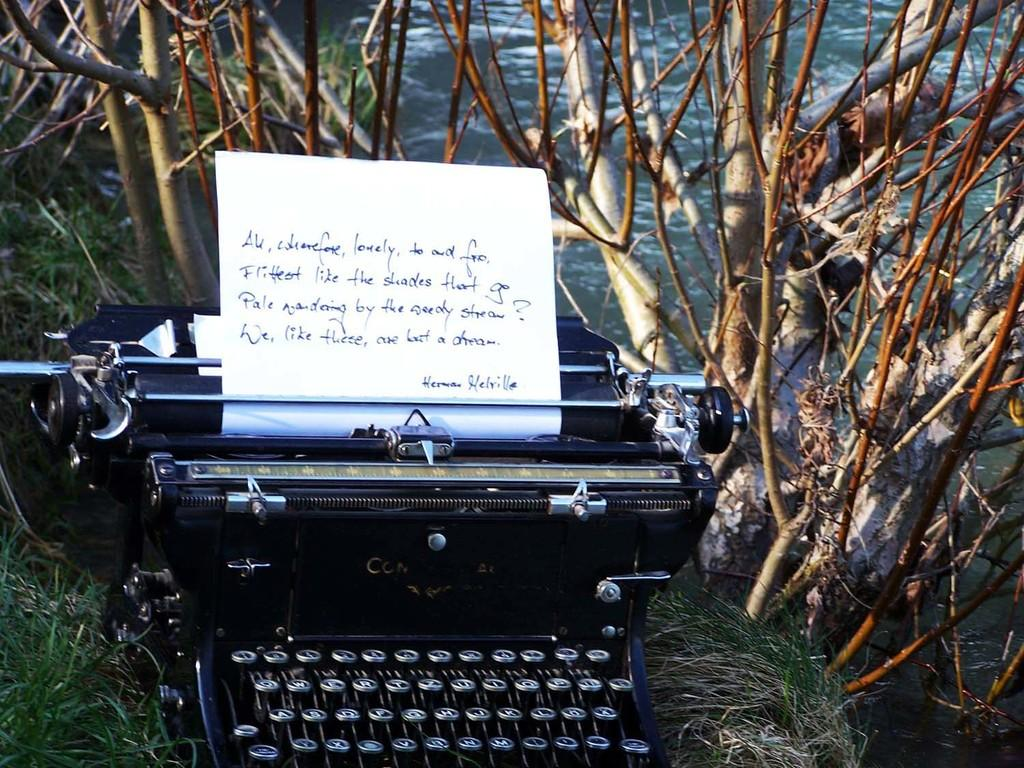<image>
Give a short and clear explanation of the subsequent image. A typewriter near a body of water with paper in it that has the words Herman Melville on the lowest line. 